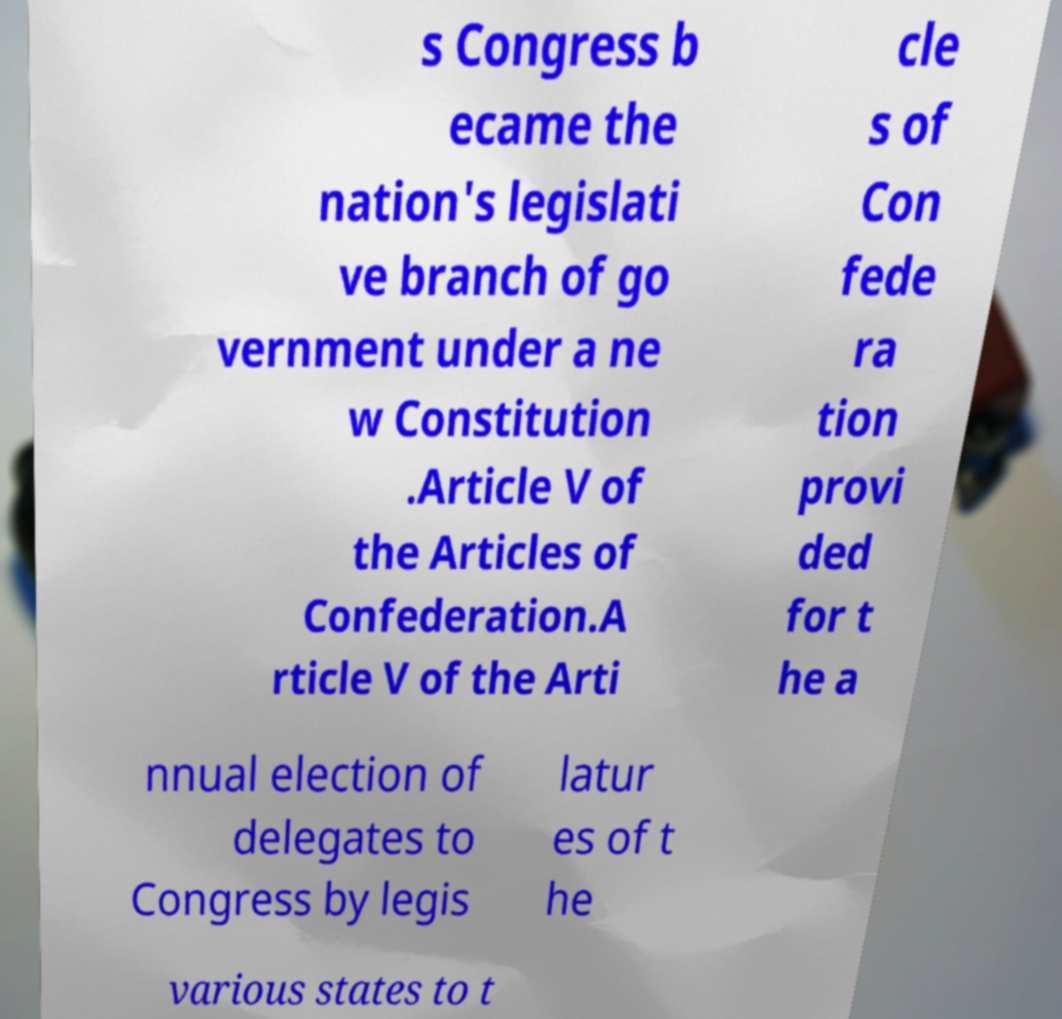What messages or text are displayed in this image? I need them in a readable, typed format. s Congress b ecame the nation's legislati ve branch of go vernment under a ne w Constitution .Article V of the Articles of Confederation.A rticle V of the Arti cle s of Con fede ra tion provi ded for t he a nnual election of delegates to Congress by legis latur es of t he various states to t 